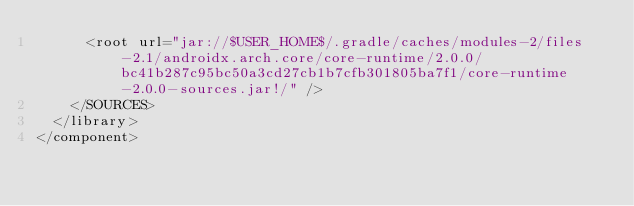<code> <loc_0><loc_0><loc_500><loc_500><_XML_>      <root url="jar://$USER_HOME$/.gradle/caches/modules-2/files-2.1/androidx.arch.core/core-runtime/2.0.0/bc41b287c95bc50a3cd27cb1b7cfb301805ba7f1/core-runtime-2.0.0-sources.jar!/" />
    </SOURCES>
  </library>
</component></code> 